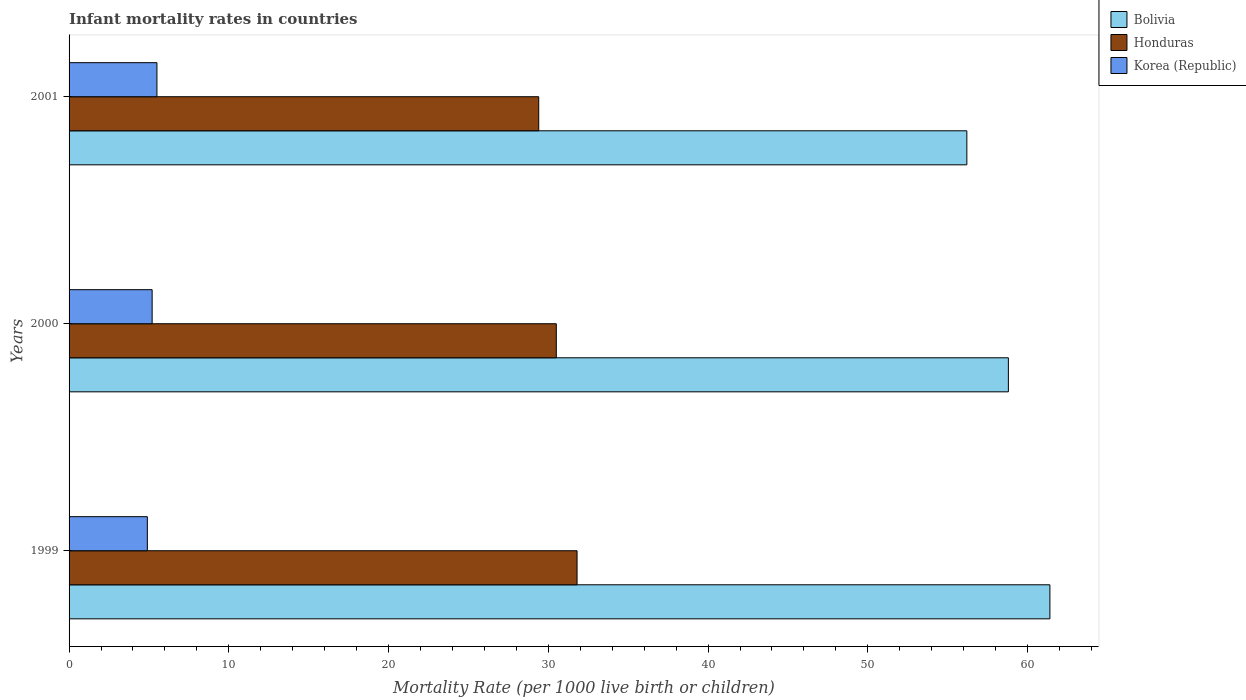How many different coloured bars are there?
Ensure brevity in your answer.  3. How many groups of bars are there?
Offer a terse response. 3. How many bars are there on the 1st tick from the top?
Your answer should be very brief. 3. How many bars are there on the 3rd tick from the bottom?
Your answer should be compact. 3. Across all years, what is the maximum infant mortality rate in Bolivia?
Offer a very short reply. 61.4. Across all years, what is the minimum infant mortality rate in Honduras?
Your response must be concise. 29.4. What is the total infant mortality rate in Korea (Republic) in the graph?
Your answer should be very brief. 15.6. What is the difference between the infant mortality rate in Korea (Republic) in 2000 and that in 2001?
Offer a very short reply. -0.3. What is the difference between the infant mortality rate in Honduras in 2000 and the infant mortality rate in Bolivia in 2001?
Ensure brevity in your answer.  -25.7. What is the average infant mortality rate in Bolivia per year?
Provide a succinct answer. 58.8. In the year 2000, what is the difference between the infant mortality rate in Korea (Republic) and infant mortality rate in Bolivia?
Your answer should be compact. -53.6. In how many years, is the infant mortality rate in Honduras greater than 54 ?
Keep it short and to the point. 0. What is the ratio of the infant mortality rate in Honduras in 1999 to that in 2001?
Ensure brevity in your answer.  1.08. Is the infant mortality rate in Honduras in 2000 less than that in 2001?
Keep it short and to the point. No. Is the difference between the infant mortality rate in Korea (Republic) in 1999 and 2000 greater than the difference between the infant mortality rate in Bolivia in 1999 and 2000?
Offer a terse response. No. What is the difference between the highest and the second highest infant mortality rate in Honduras?
Offer a very short reply. 1.3. What is the difference between the highest and the lowest infant mortality rate in Korea (Republic)?
Give a very brief answer. 0.6. In how many years, is the infant mortality rate in Honduras greater than the average infant mortality rate in Honduras taken over all years?
Your answer should be very brief. 1. Is the sum of the infant mortality rate in Honduras in 1999 and 2001 greater than the maximum infant mortality rate in Bolivia across all years?
Your answer should be compact. No. What does the 3rd bar from the top in 1999 represents?
Offer a very short reply. Bolivia. Is it the case that in every year, the sum of the infant mortality rate in Korea (Republic) and infant mortality rate in Bolivia is greater than the infant mortality rate in Honduras?
Your response must be concise. Yes. How many bars are there?
Offer a terse response. 9. How many years are there in the graph?
Make the answer very short. 3. How many legend labels are there?
Provide a short and direct response. 3. How are the legend labels stacked?
Offer a terse response. Vertical. What is the title of the graph?
Your answer should be very brief. Infant mortality rates in countries. Does "Mali" appear as one of the legend labels in the graph?
Offer a very short reply. No. What is the label or title of the X-axis?
Keep it short and to the point. Mortality Rate (per 1000 live birth or children). What is the label or title of the Y-axis?
Ensure brevity in your answer.  Years. What is the Mortality Rate (per 1000 live birth or children) of Bolivia in 1999?
Provide a short and direct response. 61.4. What is the Mortality Rate (per 1000 live birth or children) in Honduras in 1999?
Offer a terse response. 31.8. What is the Mortality Rate (per 1000 live birth or children) in Korea (Republic) in 1999?
Provide a succinct answer. 4.9. What is the Mortality Rate (per 1000 live birth or children) of Bolivia in 2000?
Your answer should be compact. 58.8. What is the Mortality Rate (per 1000 live birth or children) of Honduras in 2000?
Offer a terse response. 30.5. What is the Mortality Rate (per 1000 live birth or children) in Bolivia in 2001?
Keep it short and to the point. 56.2. What is the Mortality Rate (per 1000 live birth or children) in Honduras in 2001?
Your answer should be very brief. 29.4. Across all years, what is the maximum Mortality Rate (per 1000 live birth or children) in Bolivia?
Your response must be concise. 61.4. Across all years, what is the maximum Mortality Rate (per 1000 live birth or children) in Honduras?
Give a very brief answer. 31.8. Across all years, what is the minimum Mortality Rate (per 1000 live birth or children) in Bolivia?
Provide a short and direct response. 56.2. Across all years, what is the minimum Mortality Rate (per 1000 live birth or children) in Honduras?
Your answer should be very brief. 29.4. Across all years, what is the minimum Mortality Rate (per 1000 live birth or children) in Korea (Republic)?
Provide a succinct answer. 4.9. What is the total Mortality Rate (per 1000 live birth or children) of Bolivia in the graph?
Provide a short and direct response. 176.4. What is the total Mortality Rate (per 1000 live birth or children) of Honduras in the graph?
Give a very brief answer. 91.7. What is the difference between the Mortality Rate (per 1000 live birth or children) in Honduras in 1999 and that in 2000?
Your response must be concise. 1.3. What is the difference between the Mortality Rate (per 1000 live birth or children) of Honduras in 1999 and that in 2001?
Your answer should be compact. 2.4. What is the difference between the Mortality Rate (per 1000 live birth or children) of Bolivia in 2000 and that in 2001?
Your answer should be compact. 2.6. What is the difference between the Mortality Rate (per 1000 live birth or children) of Honduras in 2000 and that in 2001?
Offer a terse response. 1.1. What is the difference between the Mortality Rate (per 1000 live birth or children) in Bolivia in 1999 and the Mortality Rate (per 1000 live birth or children) in Honduras in 2000?
Offer a very short reply. 30.9. What is the difference between the Mortality Rate (per 1000 live birth or children) of Bolivia in 1999 and the Mortality Rate (per 1000 live birth or children) of Korea (Republic) in 2000?
Provide a succinct answer. 56.2. What is the difference between the Mortality Rate (per 1000 live birth or children) of Honduras in 1999 and the Mortality Rate (per 1000 live birth or children) of Korea (Republic) in 2000?
Offer a terse response. 26.6. What is the difference between the Mortality Rate (per 1000 live birth or children) of Bolivia in 1999 and the Mortality Rate (per 1000 live birth or children) of Korea (Republic) in 2001?
Ensure brevity in your answer.  55.9. What is the difference between the Mortality Rate (per 1000 live birth or children) in Honduras in 1999 and the Mortality Rate (per 1000 live birth or children) in Korea (Republic) in 2001?
Offer a terse response. 26.3. What is the difference between the Mortality Rate (per 1000 live birth or children) in Bolivia in 2000 and the Mortality Rate (per 1000 live birth or children) in Honduras in 2001?
Ensure brevity in your answer.  29.4. What is the difference between the Mortality Rate (per 1000 live birth or children) of Bolivia in 2000 and the Mortality Rate (per 1000 live birth or children) of Korea (Republic) in 2001?
Provide a short and direct response. 53.3. What is the difference between the Mortality Rate (per 1000 live birth or children) in Honduras in 2000 and the Mortality Rate (per 1000 live birth or children) in Korea (Republic) in 2001?
Give a very brief answer. 25. What is the average Mortality Rate (per 1000 live birth or children) of Bolivia per year?
Your answer should be compact. 58.8. What is the average Mortality Rate (per 1000 live birth or children) in Honduras per year?
Ensure brevity in your answer.  30.57. In the year 1999, what is the difference between the Mortality Rate (per 1000 live birth or children) of Bolivia and Mortality Rate (per 1000 live birth or children) of Honduras?
Ensure brevity in your answer.  29.6. In the year 1999, what is the difference between the Mortality Rate (per 1000 live birth or children) in Bolivia and Mortality Rate (per 1000 live birth or children) in Korea (Republic)?
Provide a short and direct response. 56.5. In the year 1999, what is the difference between the Mortality Rate (per 1000 live birth or children) of Honduras and Mortality Rate (per 1000 live birth or children) of Korea (Republic)?
Your answer should be compact. 26.9. In the year 2000, what is the difference between the Mortality Rate (per 1000 live birth or children) in Bolivia and Mortality Rate (per 1000 live birth or children) in Honduras?
Provide a short and direct response. 28.3. In the year 2000, what is the difference between the Mortality Rate (per 1000 live birth or children) of Bolivia and Mortality Rate (per 1000 live birth or children) of Korea (Republic)?
Provide a succinct answer. 53.6. In the year 2000, what is the difference between the Mortality Rate (per 1000 live birth or children) in Honduras and Mortality Rate (per 1000 live birth or children) in Korea (Republic)?
Give a very brief answer. 25.3. In the year 2001, what is the difference between the Mortality Rate (per 1000 live birth or children) in Bolivia and Mortality Rate (per 1000 live birth or children) in Honduras?
Give a very brief answer. 26.8. In the year 2001, what is the difference between the Mortality Rate (per 1000 live birth or children) of Bolivia and Mortality Rate (per 1000 live birth or children) of Korea (Republic)?
Your response must be concise. 50.7. In the year 2001, what is the difference between the Mortality Rate (per 1000 live birth or children) of Honduras and Mortality Rate (per 1000 live birth or children) of Korea (Republic)?
Offer a very short reply. 23.9. What is the ratio of the Mortality Rate (per 1000 live birth or children) in Bolivia in 1999 to that in 2000?
Provide a short and direct response. 1.04. What is the ratio of the Mortality Rate (per 1000 live birth or children) in Honduras in 1999 to that in 2000?
Your answer should be compact. 1.04. What is the ratio of the Mortality Rate (per 1000 live birth or children) in Korea (Republic) in 1999 to that in 2000?
Make the answer very short. 0.94. What is the ratio of the Mortality Rate (per 1000 live birth or children) in Bolivia in 1999 to that in 2001?
Ensure brevity in your answer.  1.09. What is the ratio of the Mortality Rate (per 1000 live birth or children) of Honduras in 1999 to that in 2001?
Make the answer very short. 1.08. What is the ratio of the Mortality Rate (per 1000 live birth or children) in Korea (Republic) in 1999 to that in 2001?
Your answer should be very brief. 0.89. What is the ratio of the Mortality Rate (per 1000 live birth or children) in Bolivia in 2000 to that in 2001?
Provide a succinct answer. 1.05. What is the ratio of the Mortality Rate (per 1000 live birth or children) in Honduras in 2000 to that in 2001?
Your answer should be very brief. 1.04. What is the ratio of the Mortality Rate (per 1000 live birth or children) of Korea (Republic) in 2000 to that in 2001?
Offer a very short reply. 0.95. What is the difference between the highest and the second highest Mortality Rate (per 1000 live birth or children) of Bolivia?
Provide a short and direct response. 2.6. What is the difference between the highest and the second highest Mortality Rate (per 1000 live birth or children) in Honduras?
Keep it short and to the point. 1.3. What is the difference between the highest and the lowest Mortality Rate (per 1000 live birth or children) of Bolivia?
Keep it short and to the point. 5.2. 